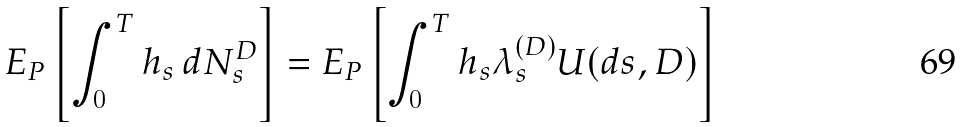<formula> <loc_0><loc_0><loc_500><loc_500>E _ { P } \left [ \int _ { 0 } ^ { T } h _ { s } \, d N _ { s } ^ { D } \right ] = E _ { P } \left [ \int _ { 0 } ^ { T } h _ { s } \lambda _ { s } ^ { ( D ) } U ( d s , D ) \right ]</formula> 